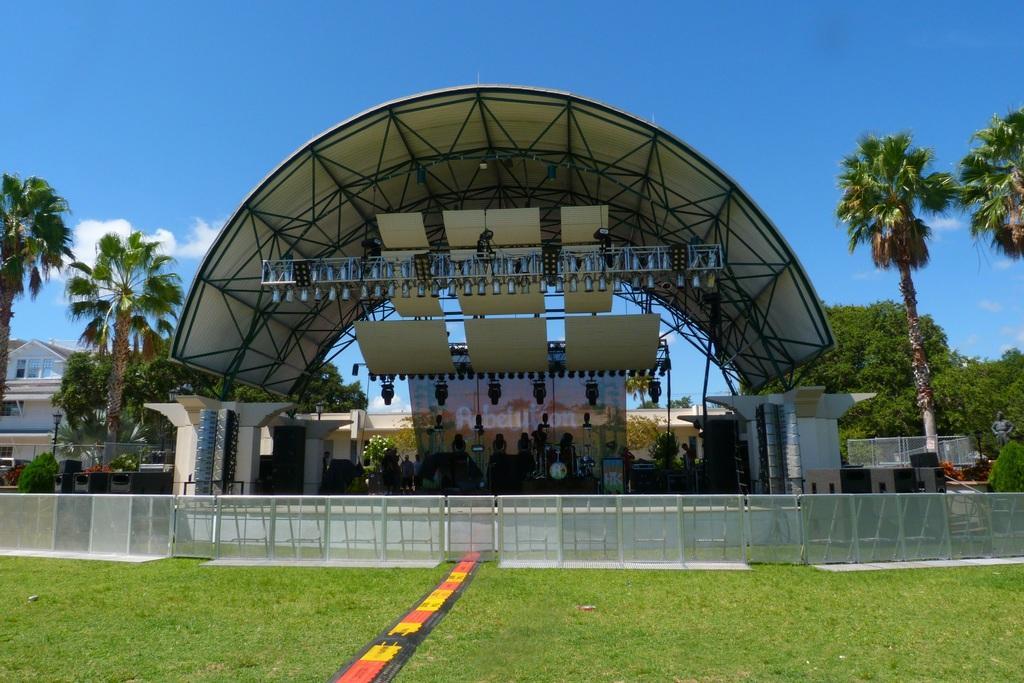How would you summarize this image in a sentence or two? In this image there are few people under a curved roof, there are few objects hanging from the roof, few trees, buildings, a fence, grass and some clouds in the sky. 